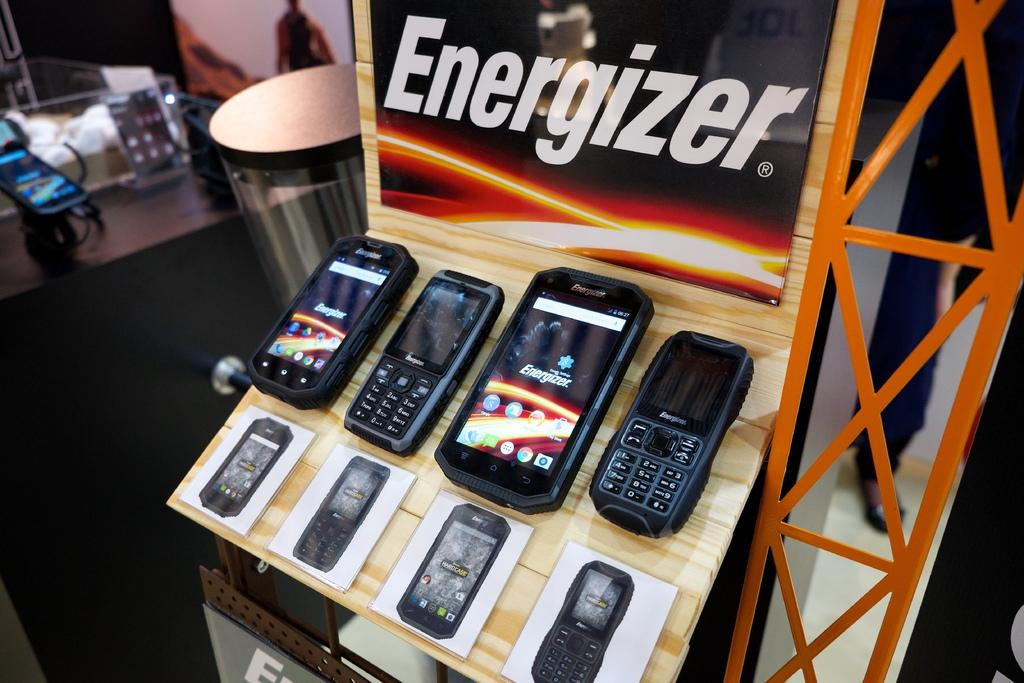Provide a one-sentence caption for the provided image. The cell phone display advertises the Energizer battery brand. 